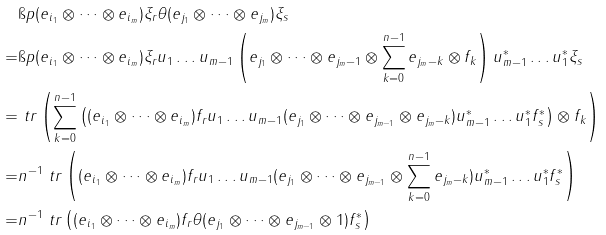<formula> <loc_0><loc_0><loc_500><loc_500>& { \i p { ( e _ { i _ { 1 } } \otimes \dots \otimes e _ { i _ { m } } ) \xi _ { r } \theta ( e _ { j _ { 1 } } \otimes \dots \otimes e _ { j _ { m } } ) } { \xi _ { s } } } \\ = & { \i p { ( e _ { i _ { 1 } } \otimes \dots \otimes e _ { i _ { m } } ) \xi _ { r } u _ { 1 } \dots u _ { m - 1 } \left ( e _ { j _ { 1 } } \otimes \dots \otimes e _ { j _ { m } - 1 } \otimes \sum _ { k = 0 } ^ { n - 1 } e _ { j _ { m } - k } \otimes f _ { k } \right ) u _ { m - 1 } ^ { * } \dots u _ { 1 } ^ { * } } { \xi _ { s } } } \\ = & \ t r \left ( \sum _ { k = 0 } ^ { n - 1 } \left ( ( e _ { i _ { 1 } } \otimes \dots \otimes e _ { i _ { m } } ) f _ { r } u _ { 1 } \dots u _ { m - 1 } ( e _ { j _ { 1 } } \otimes \dots \otimes e _ { j _ { m - 1 } } \otimes e _ { j _ { m } - k } ) u _ { m - 1 } ^ { * } \dots u _ { 1 } ^ { * } f _ { s } ^ { * } \right ) \otimes f _ { k } \right ) \\ = & n ^ { - 1 } \ t r \left ( ( e _ { i _ { 1 } } \otimes \dots \otimes e _ { i _ { m } } ) f _ { r } u _ { 1 } \dots u _ { m - 1 } ( e _ { j _ { 1 } } \otimes \dots \otimes e _ { j _ { m - 1 } } \otimes \sum _ { k = 0 } ^ { n - 1 } e _ { j _ { m } - k } ) u _ { m - 1 } ^ { * } \dots u _ { 1 } ^ { * } f _ { s } ^ { * } \right ) \\ = & n ^ { - 1 } \ t r \left ( ( e _ { i _ { 1 } } \otimes \dots \otimes e _ { i _ { m } } ) f _ { r } \theta ( e _ { j _ { 1 } } \otimes \dots \otimes e _ { j _ { m - 1 } } \otimes 1 ) f _ { s } ^ { * } \right )</formula> 